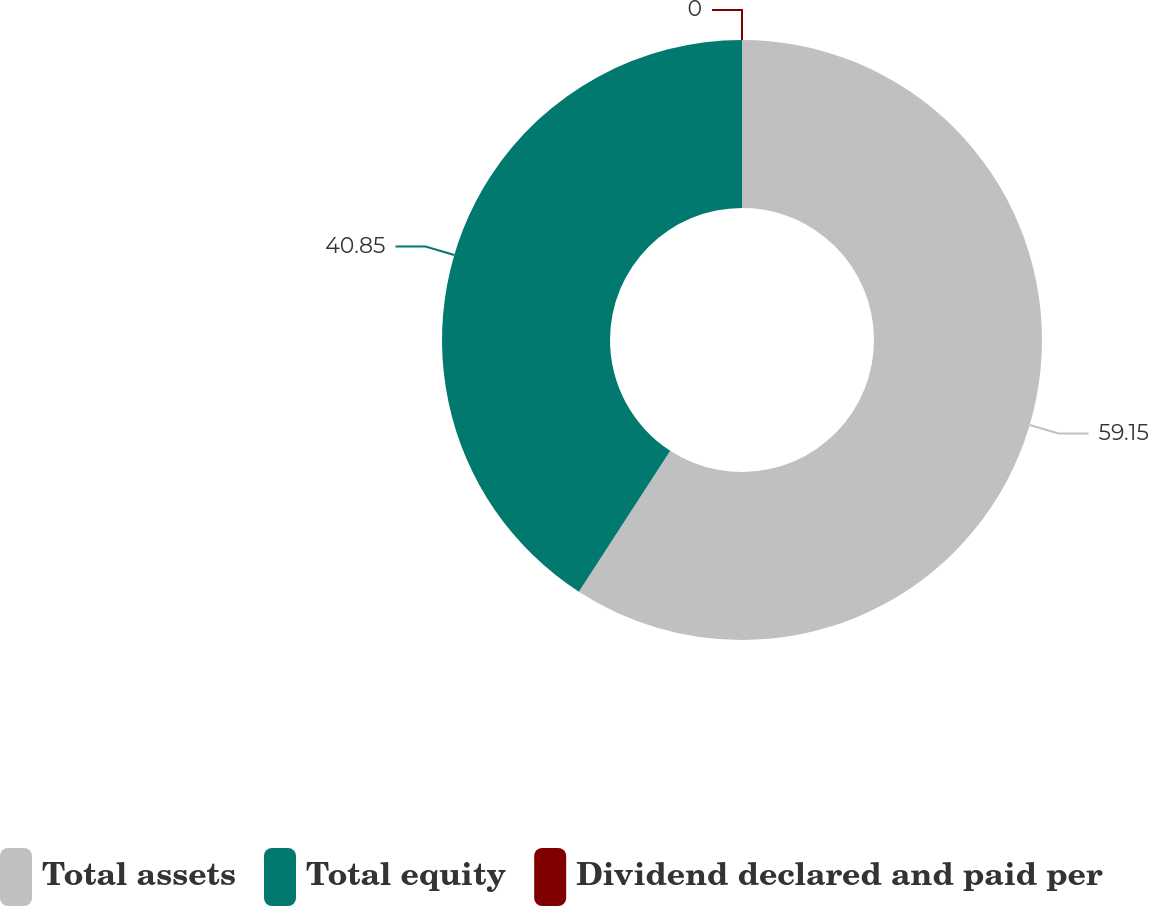Convert chart to OTSL. <chart><loc_0><loc_0><loc_500><loc_500><pie_chart><fcel>Total assets<fcel>Total equity<fcel>Dividend declared and paid per<nl><fcel>59.15%<fcel>40.85%<fcel>0.0%<nl></chart> 